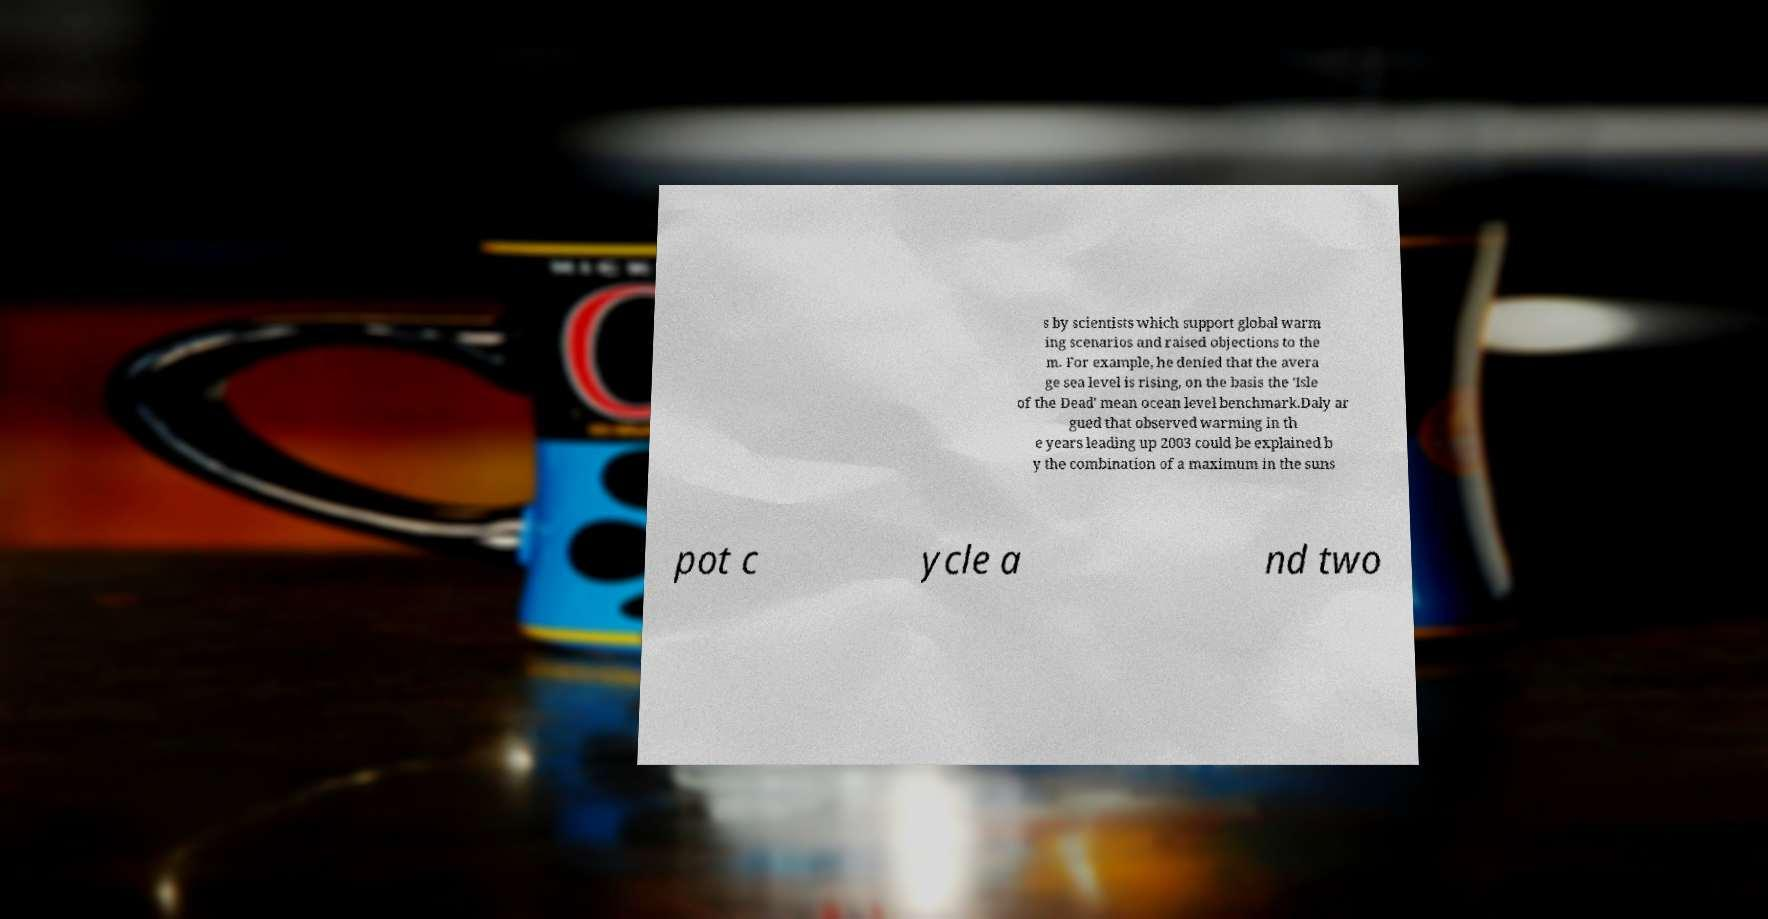I need the written content from this picture converted into text. Can you do that? s by scientists which support global warm ing scenarios and raised objections to the m. For example, he denied that the avera ge sea level is rising, on the basis the 'Isle of the Dead' mean ocean level benchmark.Daly ar gued that observed warming in th e years leading up 2003 could be explained b y the combination of a maximum in the suns pot c ycle a nd two 